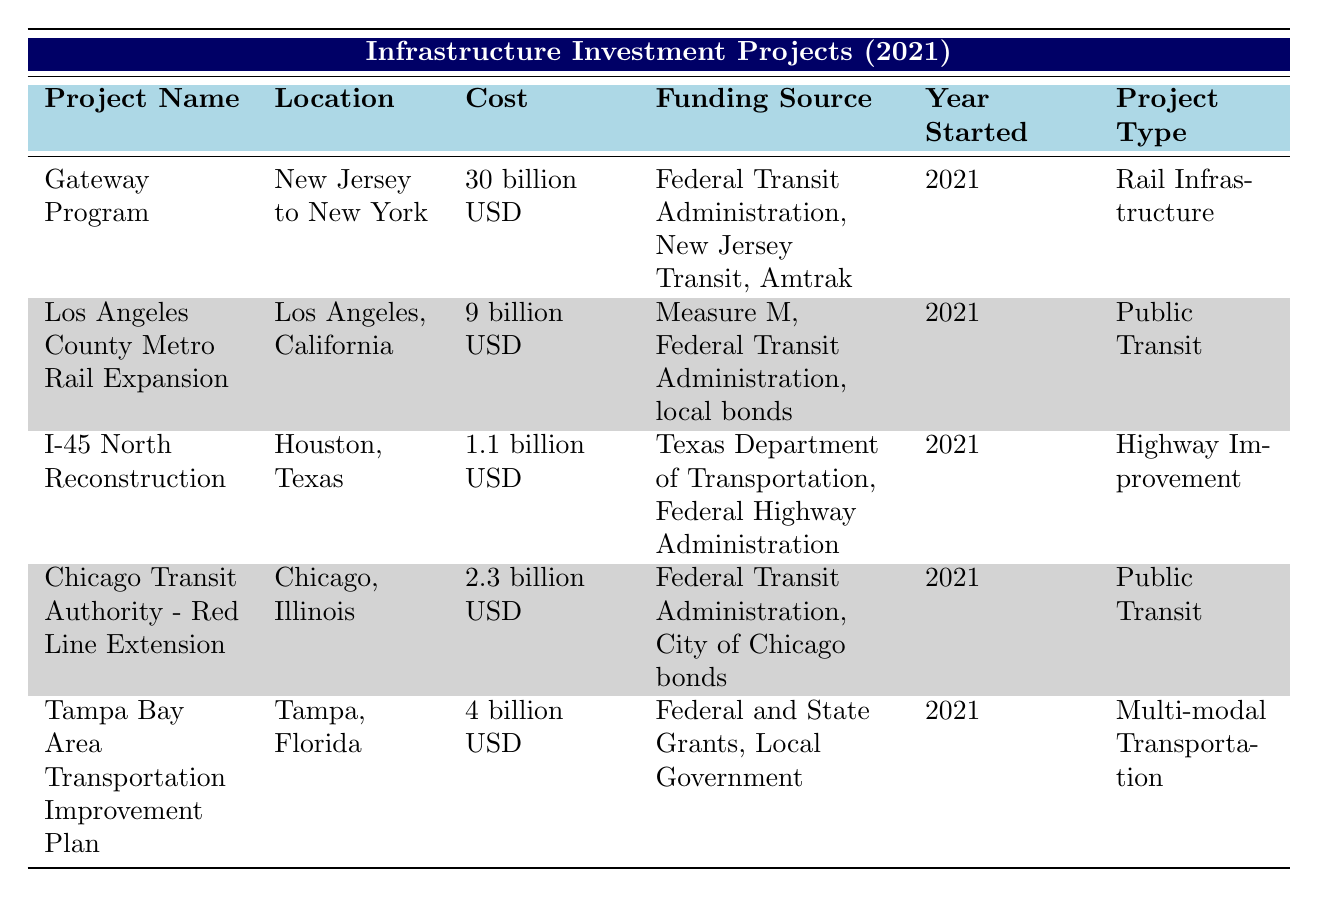What is the total cost of all the infrastructure projects listed? To find the total cost, we'll sum up the individual project costs: 30 billion (Gateway Program) + 9 billion (Los Angeles County Metro Rail Expansion) + 1.1 billion (I-45 North Reconstruction) + 2.3 billion (Chicago Transit Authority - Red Line Extension) + 4 billion (Tampa Bay Area Transportation Improvement Plan) = 46.4 billion USD
Answer: 46.4 billion USD Which project has the highest cost? By reviewing the project costs in the table, 30 billion USD (Gateway Program) is the highest amount compared to others such as 9 billion, 1.1 billion, 2.3 billion, and 4 billion.
Answer: Gateway Program Is the I-45 North Reconstruction project related to public transit? The I-45 North Reconstruction project categorized as "Highway Improvement" indicates that it is not related to public transit, which is confirmed by its classification and the lack of public transit funding sources.
Answer: No Which projects received funding from the Federal Transit Administration? The projects funded by the Federal Transit Administration are the Gateway Program, Los Angeles County Metro Rail Expansion, and Chicago Transit Authority - Red Line Extension based on the funding sources indicated in the table.
Answer: Gateway Program, Los Angeles County Metro Rail Expansion, Chicago Transit Authority - Red Line Extension What is the average project cost for the Public Transit projects? There are two Public Transit projects: Los Angeles County Metro Rail Expansion (9 billion) and Chicago Transit Authority - Red Line Extension (2.3 billion). The total cost for these two projects is 9 + 2.3 = 11.3 billion USD. To find the average, divide the total cost by the number of projects: 11.3 billion / 2 = 5.65 billion USD.
Answer: 5.65 billion USD 